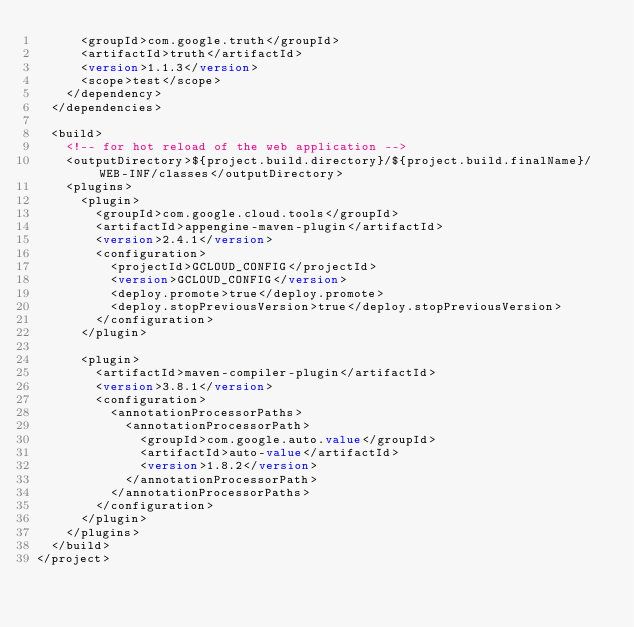Convert code to text. <code><loc_0><loc_0><loc_500><loc_500><_XML_>      <groupId>com.google.truth</groupId>
      <artifactId>truth</artifactId>
      <version>1.1.3</version>
      <scope>test</scope>
    </dependency>
  </dependencies>

  <build>
    <!-- for hot reload of the web application -->
    <outputDirectory>${project.build.directory}/${project.build.finalName}/WEB-INF/classes</outputDirectory>
    <plugins>
      <plugin>
        <groupId>com.google.cloud.tools</groupId>
        <artifactId>appengine-maven-plugin</artifactId>
        <version>2.4.1</version>
        <configuration>
          <projectId>GCLOUD_CONFIG</projectId>
          <version>GCLOUD_CONFIG</version>
          <deploy.promote>true</deploy.promote>
          <deploy.stopPreviousVersion>true</deploy.stopPreviousVersion>
        </configuration>
      </plugin>

      <plugin>
        <artifactId>maven-compiler-plugin</artifactId>
        <version>3.8.1</version>
        <configuration>
          <annotationProcessorPaths>
            <annotationProcessorPath>
              <groupId>com.google.auto.value</groupId>
              <artifactId>auto-value</artifactId>
              <version>1.8.2</version>
            </annotationProcessorPath>
          </annotationProcessorPaths>
        </configuration>
      </plugin>
    </plugins>
  </build>
</project>
</code> 